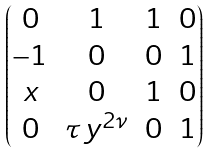<formula> <loc_0><loc_0><loc_500><loc_500>\begin{pmatrix} 0 & 1 & 1 & 0 \\ - 1 & 0 & 0 & 1 \\ x & 0 & 1 & 0 \\ 0 & \tau \, y ^ { 2 \nu } & 0 & 1 \end{pmatrix}</formula> 